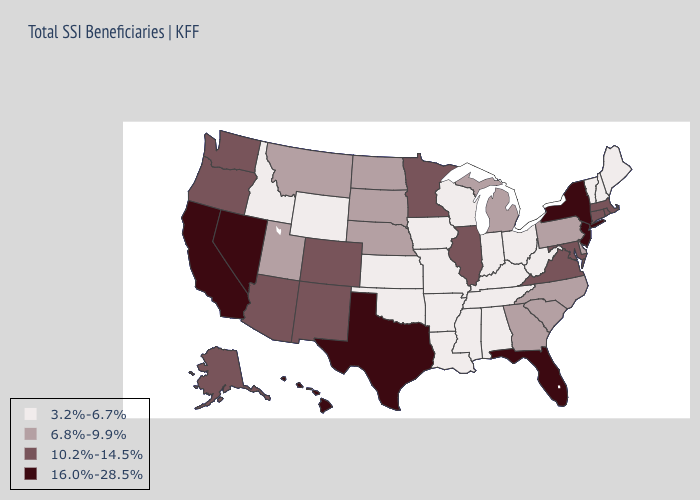Name the states that have a value in the range 16.0%-28.5%?
Be succinct. California, Florida, Hawaii, Nevada, New Jersey, New York, Texas. Does Alaska have a higher value than Arkansas?
Short answer required. Yes. What is the lowest value in states that border Kansas?
Keep it brief. 3.2%-6.7%. Which states have the lowest value in the South?
Be succinct. Alabama, Arkansas, Kentucky, Louisiana, Mississippi, Oklahoma, Tennessee, West Virginia. Does South Dakota have the highest value in the MidWest?
Write a very short answer. No. Does Florida have the highest value in the USA?
Be succinct. Yes. Among the states that border Virginia , which have the lowest value?
Give a very brief answer. Kentucky, Tennessee, West Virginia. Does Nevada have the highest value in the West?
Concise answer only. Yes. Does Illinois have the highest value in the MidWest?
Write a very short answer. Yes. Does New York have the highest value in the Northeast?
Answer briefly. Yes. Among the states that border Nevada , does Oregon have the highest value?
Quick response, please. No. What is the value of Maryland?
Be succinct. 10.2%-14.5%. What is the lowest value in the USA?
Answer briefly. 3.2%-6.7%. Which states hav the highest value in the MidWest?
Answer briefly. Illinois, Minnesota. Name the states that have a value in the range 10.2%-14.5%?
Answer briefly. Alaska, Arizona, Colorado, Connecticut, Illinois, Maryland, Massachusetts, Minnesota, New Mexico, Oregon, Rhode Island, Virginia, Washington. 